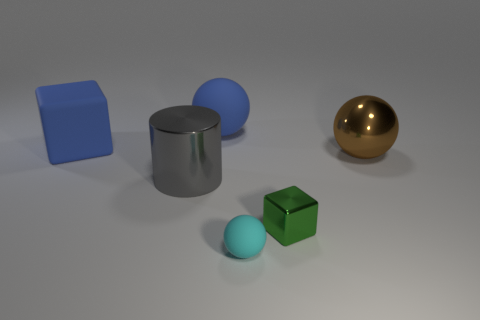Add 3 cyan spheres. How many objects exist? 9 Subtract all blocks. How many objects are left? 4 Subtract 0 purple spheres. How many objects are left? 6 Subtract all green blocks. Subtract all big brown shiny cubes. How many objects are left? 5 Add 5 cyan rubber spheres. How many cyan rubber spheres are left? 6 Add 4 large brown metallic objects. How many large brown metallic objects exist? 5 